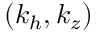Convert formula to latex. <formula><loc_0><loc_0><loc_500><loc_500>( k _ { h } , k _ { z } )</formula> 